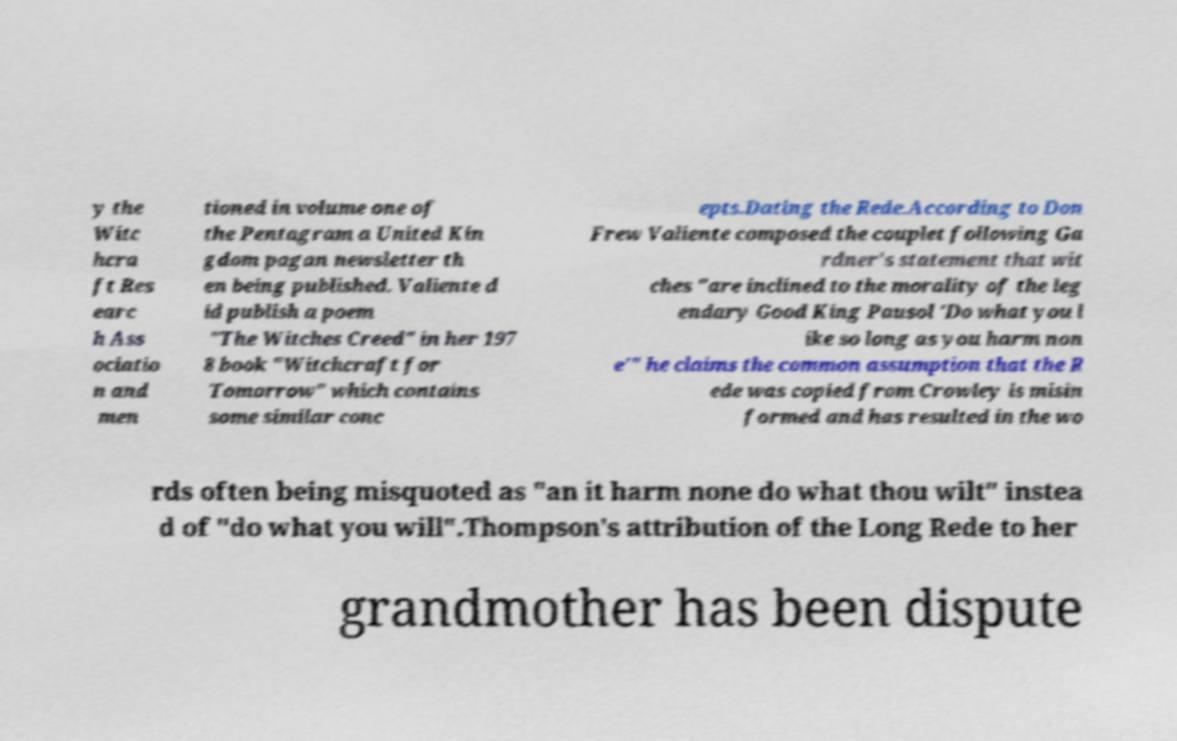What messages or text are displayed in this image? I need them in a readable, typed format. y the Witc hcra ft Res earc h Ass ociatio n and men tioned in volume one of the Pentagram a United Kin gdom pagan newsletter th en being published. Valiente d id publish a poem "The Witches Creed" in her 197 8 book "Witchcraft for Tomorrow" which contains some similar conc epts.Dating the Rede.According to Don Frew Valiente composed the couplet following Ga rdner's statement that wit ches "are inclined to the morality of the leg endary Good King Pausol 'Do what you l ike so long as you harm non e'" he claims the common assumption that the R ede was copied from Crowley is misin formed and has resulted in the wo rds often being misquoted as "an it harm none do what thou wilt" instea d of "do what you will".Thompson's attribution of the Long Rede to her grandmother has been dispute 